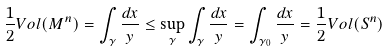Convert formula to latex. <formula><loc_0><loc_0><loc_500><loc_500>\frac { 1 } { 2 } V o l ( M ^ { n } ) = \int _ { \gamma } \frac { d x } { y } \leq \sup _ { \gamma } \int _ { \gamma } \frac { d x } { y } = \int _ { \gamma _ { 0 } } \frac { d x } { y } = \frac { 1 } { 2 } V o l ( S ^ { n } )</formula> 